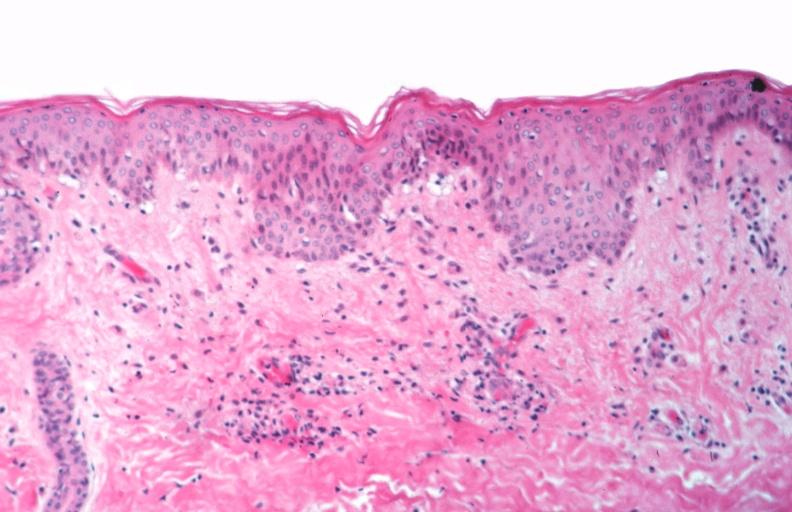where is this?
Answer the question using a single word or phrase. Skin 